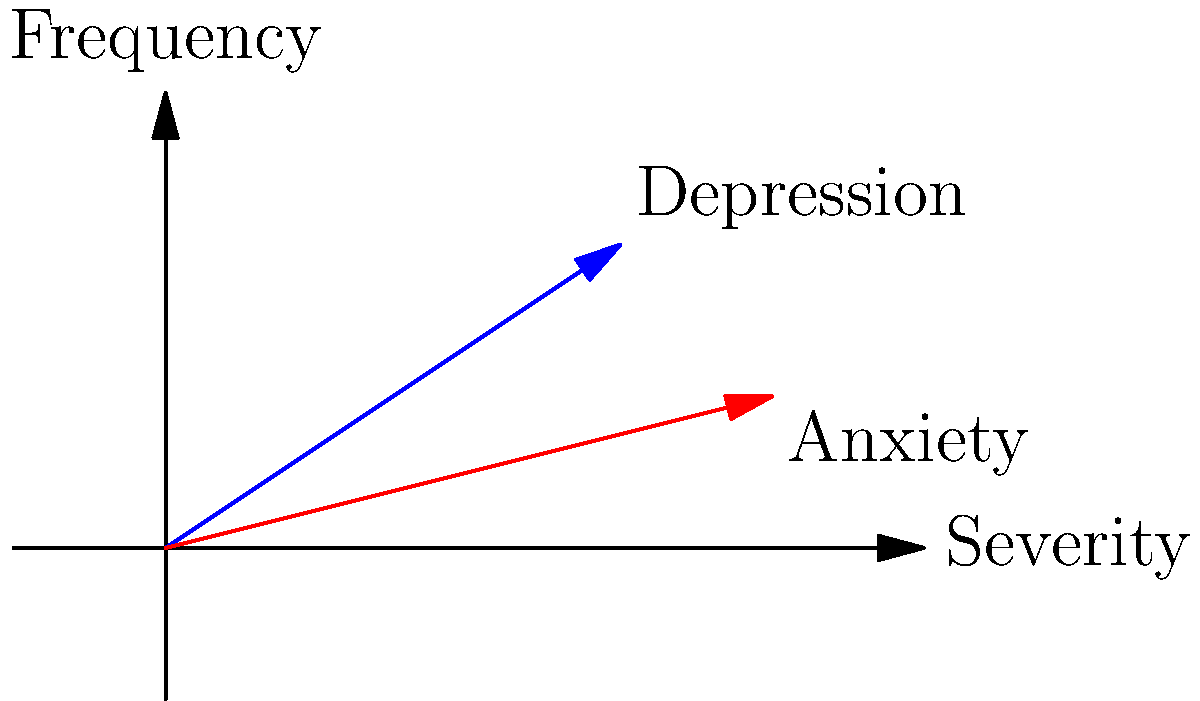In the context of mental health symptoms associated with an HIV/AIDS diagnosis, two vectors represent Depression (blue) and Anxiety (red) on a graph where the x-axis denotes symptom severity and the y-axis denotes frequency. Given that Depression is represented by vector $\mathbf{a} = (3, 2)$ and Anxiety by vector $\mathbf{b} = (4, 1)$, calculate their dot product. What does this result suggest about the relationship between these two symptoms? To solve this problem, we'll follow these steps:

1) Recall the formula for the dot product of two vectors:
   $\mathbf{a} \cdot \mathbf{b} = a_x b_x + a_y b_y$

2) Substitute the given values:
   $\mathbf{a} = (3, 2)$ and $\mathbf{b} = (4, 1)$

3) Calculate the dot product:
   $\mathbf{a} \cdot \mathbf{b} = (3 \times 4) + (2 \times 1) = 12 + 2 = 14$

4) Interpret the result:
   A positive dot product suggests that these symptoms have a tendency to occur together or in the same direction. The magnitude of 14 indicates a moderately strong positive correlation.

5) In the context of mental health and HIV/AIDS:
   This result suggests that for this patient, depression and anxiety symptoms often co-occur. When one symptom increases in severity or frequency, the other is likely to increase as well. This information can be valuable for developing a comprehensive treatment plan that addresses both symptoms simultaneously.
Answer: 14; positive correlation between depression and anxiety symptoms 